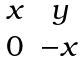<formula> <loc_0><loc_0><loc_500><loc_500>\begin{matrix} x & y \\ 0 & - x \end{matrix}</formula> 